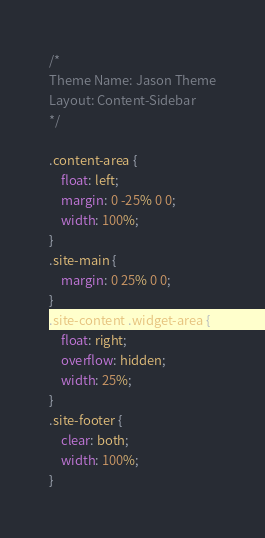<code> <loc_0><loc_0><loc_500><loc_500><_CSS_>/*
Theme Name: Jason Theme
Layout: Content-Sidebar
*/

.content-area {
	float: left;
	margin: 0 -25% 0 0;
	width: 100%;
}
.site-main {
	margin: 0 25% 0 0;
}
.site-content .widget-area {
	float: right;
	overflow: hidden;
	width: 25%;
}
.site-footer {
	clear: both;
	width: 100%;
}</code> 